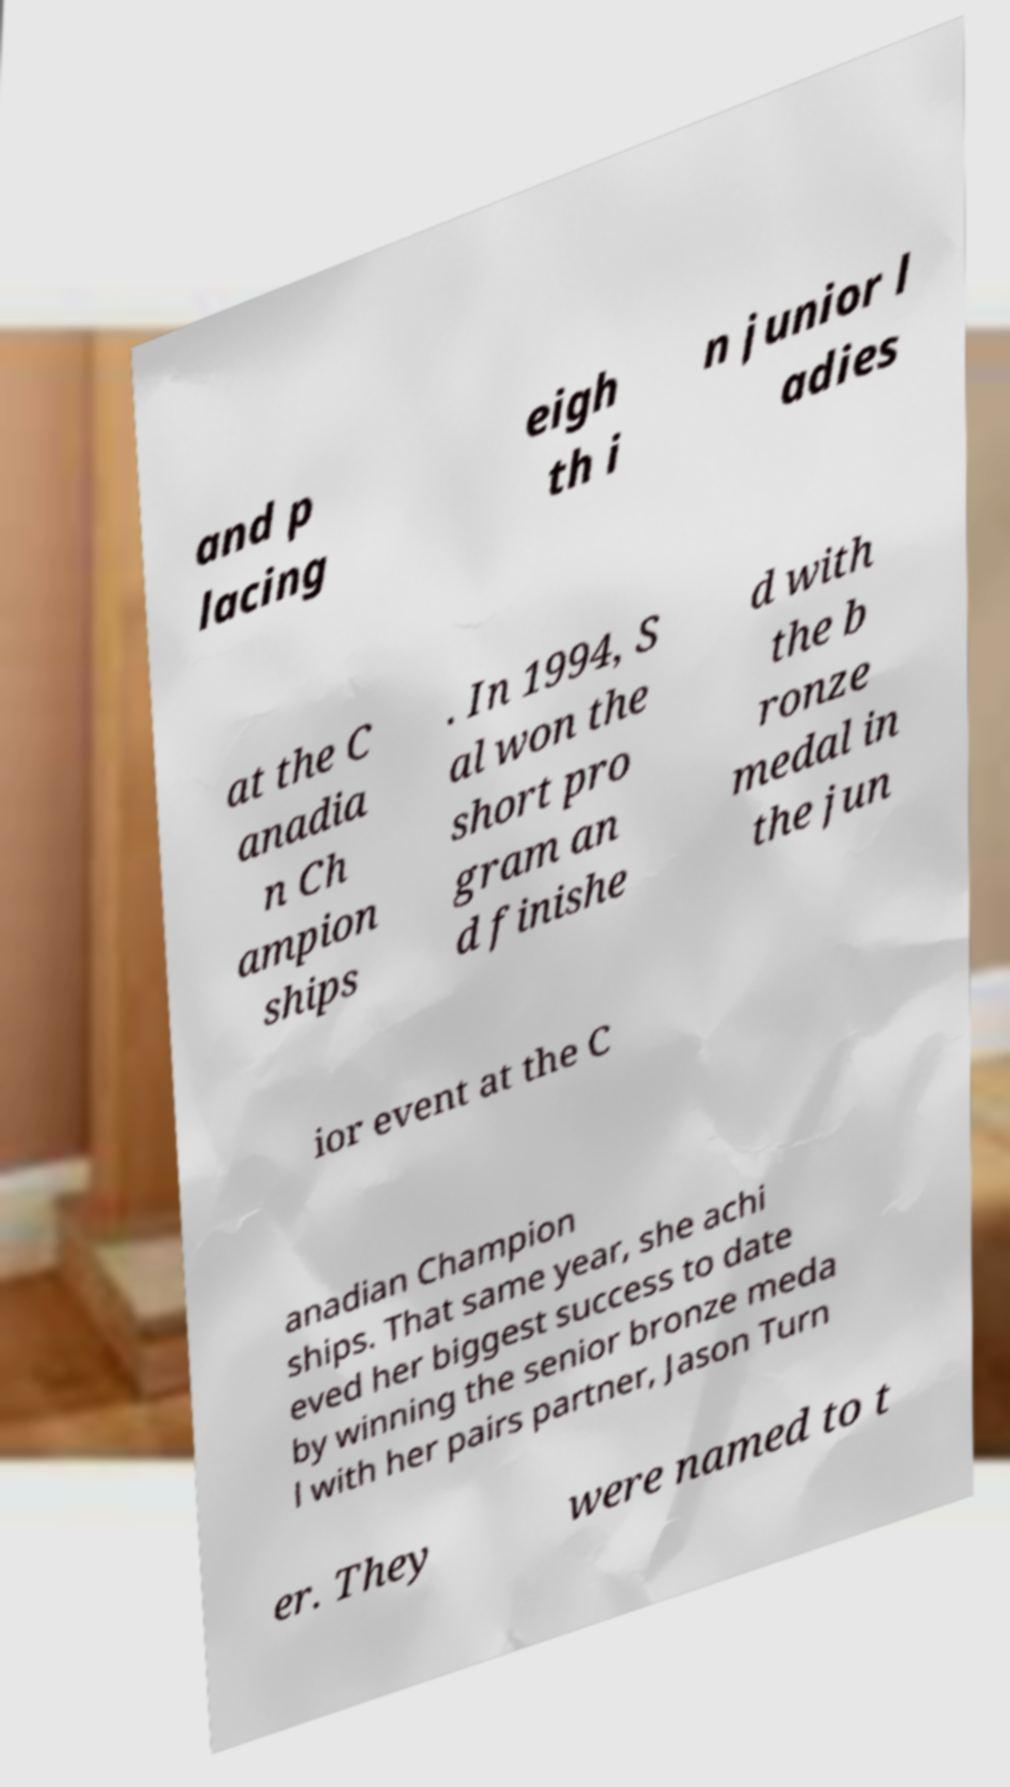Please read and relay the text visible in this image. What does it say? and p lacing eigh th i n junior l adies at the C anadia n Ch ampion ships . In 1994, S al won the short pro gram an d finishe d with the b ronze medal in the jun ior event at the C anadian Champion ships. That same year, she achi eved her biggest success to date by winning the senior bronze meda l with her pairs partner, Jason Turn er. They were named to t 